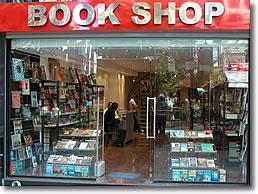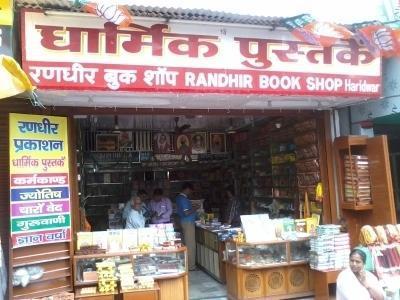The first image is the image on the left, the second image is the image on the right. Assess this claim about the two images: "A person is sitting on the ground in front of a store in the right image.". Correct or not? Answer yes or no. Yes. 